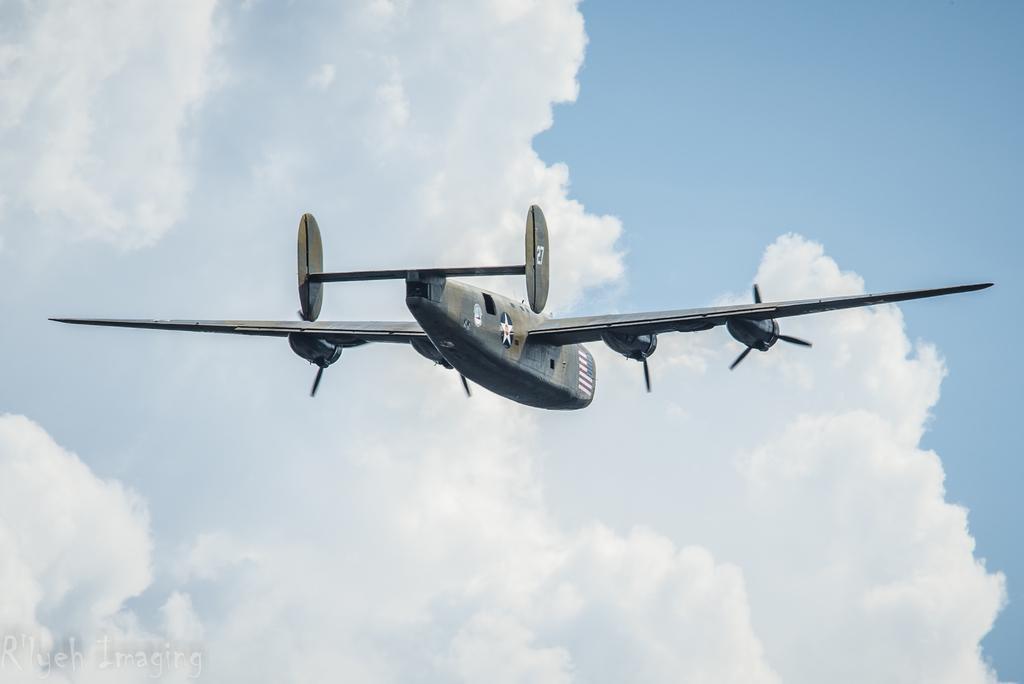Please provide a concise description of this image. In this image I can see the aircraft which is grey and white in color is flying in the air and in the background I can see the sky which is blue and white in color. 